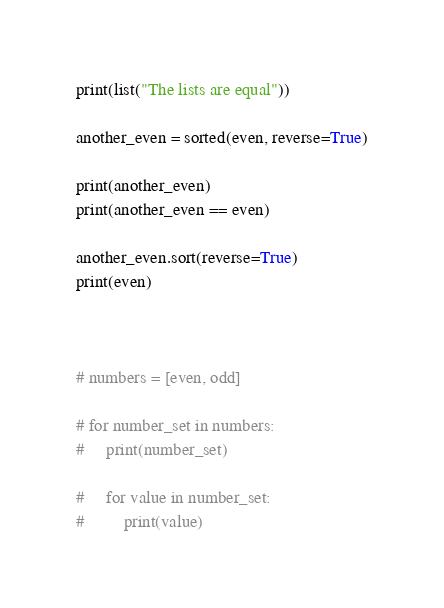<code> <loc_0><loc_0><loc_500><loc_500><_Python_>print(list("The lists are equal"))

another_even = sorted(even, reverse=True)

print(another_even)
print(another_even == even)

another_even.sort(reverse=True)
print(even)



# numbers = [even, odd]

# for number_set in numbers:
#     print(number_set)

#     for value in number_set:
#         print(value)
</code> 